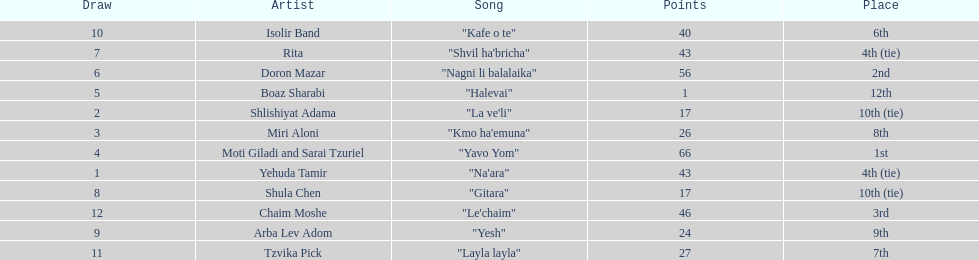Compare draws, which had the least amount of points? Boaz Sharabi. 